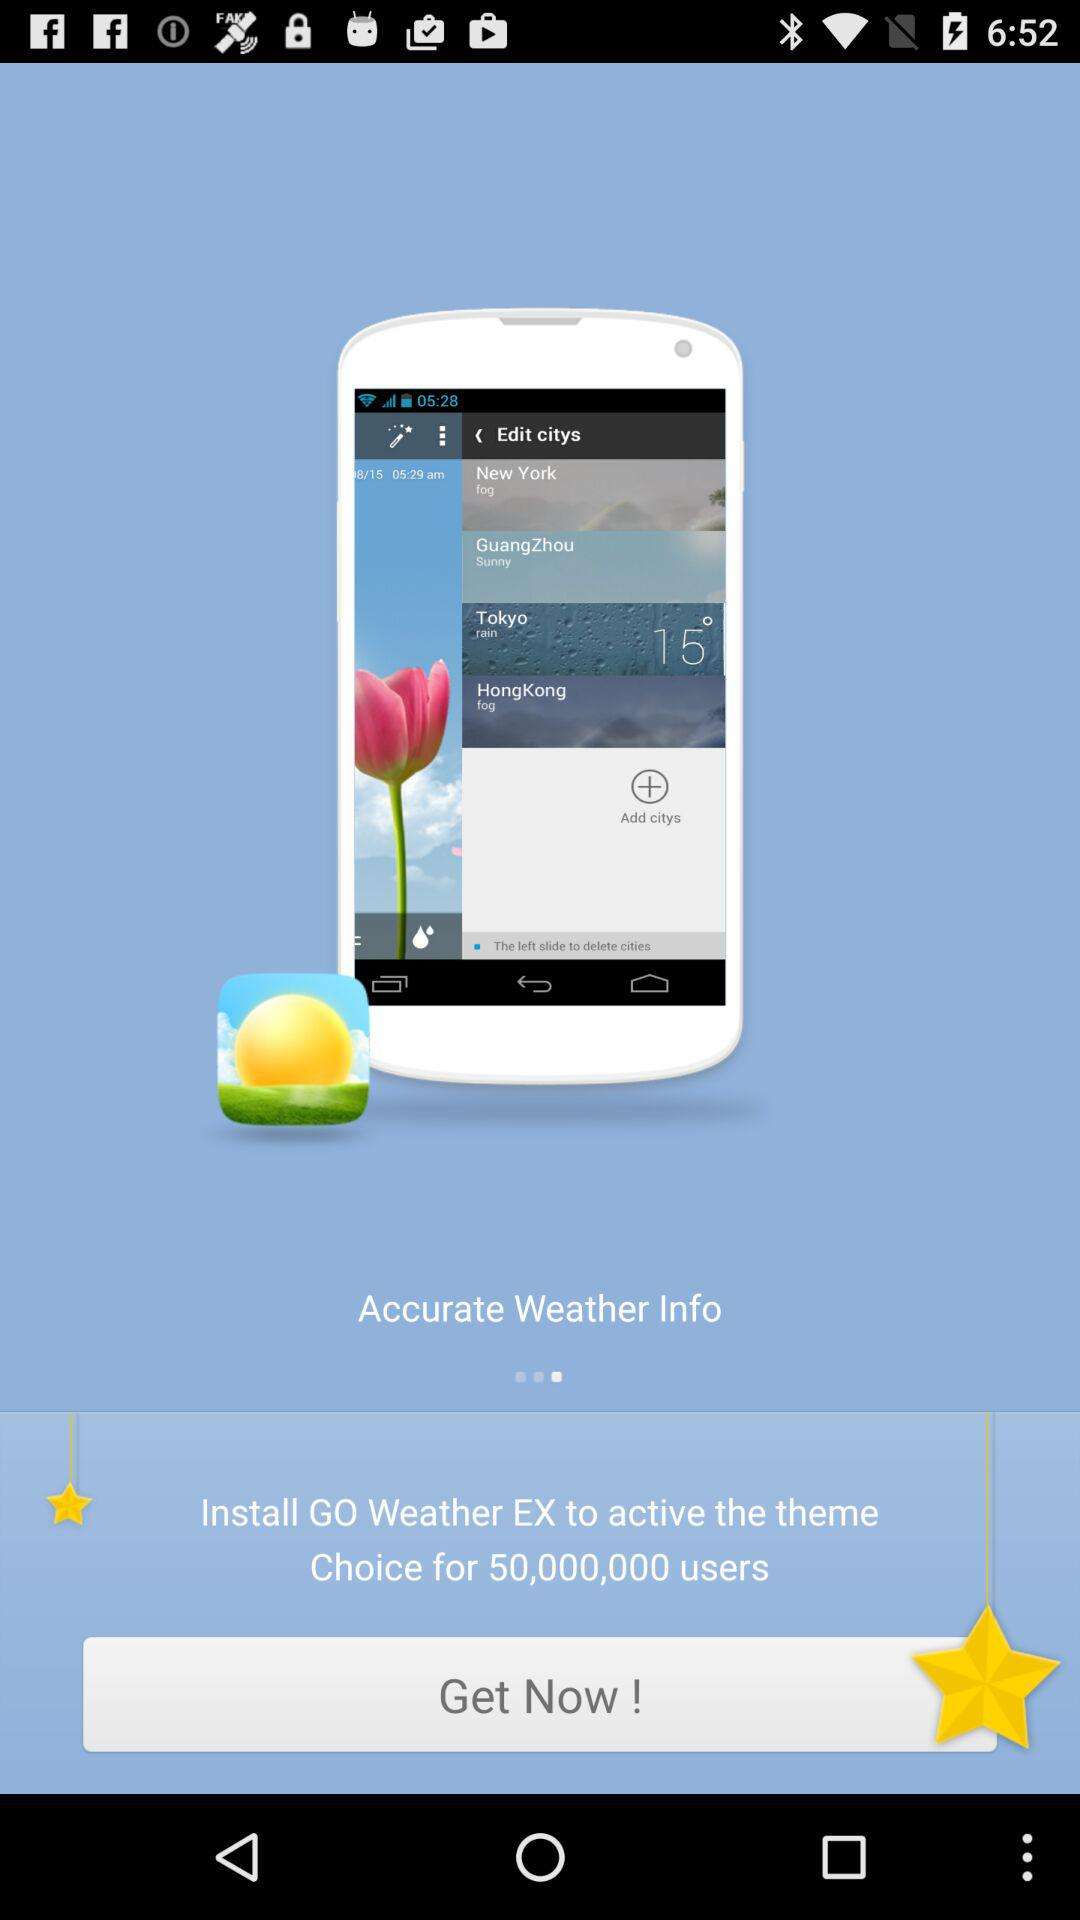What do we need to do to activate the theme choice for 50,000,000 users? You need to install "GO Weather EX" to activate the theme choice for 50,000,000 users. 